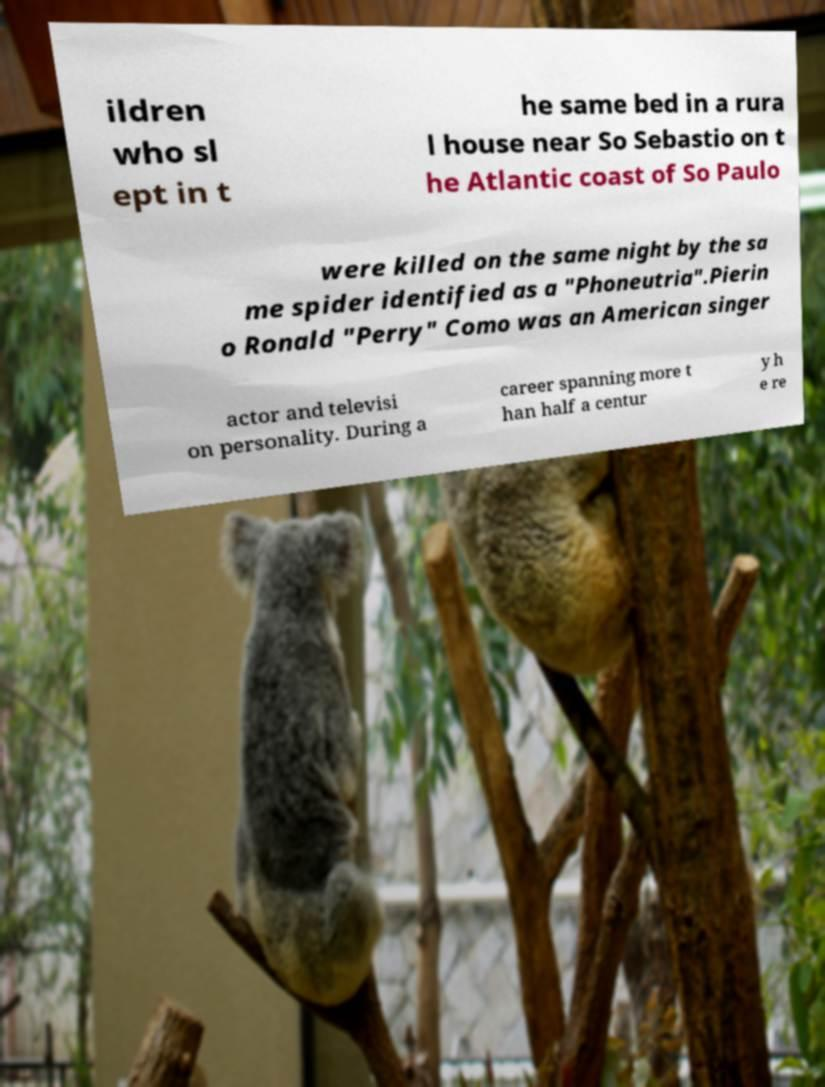Can you read and provide the text displayed in the image?This photo seems to have some interesting text. Can you extract and type it out for me? ildren who sl ept in t he same bed in a rura l house near So Sebastio on t he Atlantic coast of So Paulo were killed on the same night by the sa me spider identified as a "Phoneutria".Pierin o Ronald "Perry" Como was an American singer actor and televisi on personality. During a career spanning more t han half a centur y h e re 